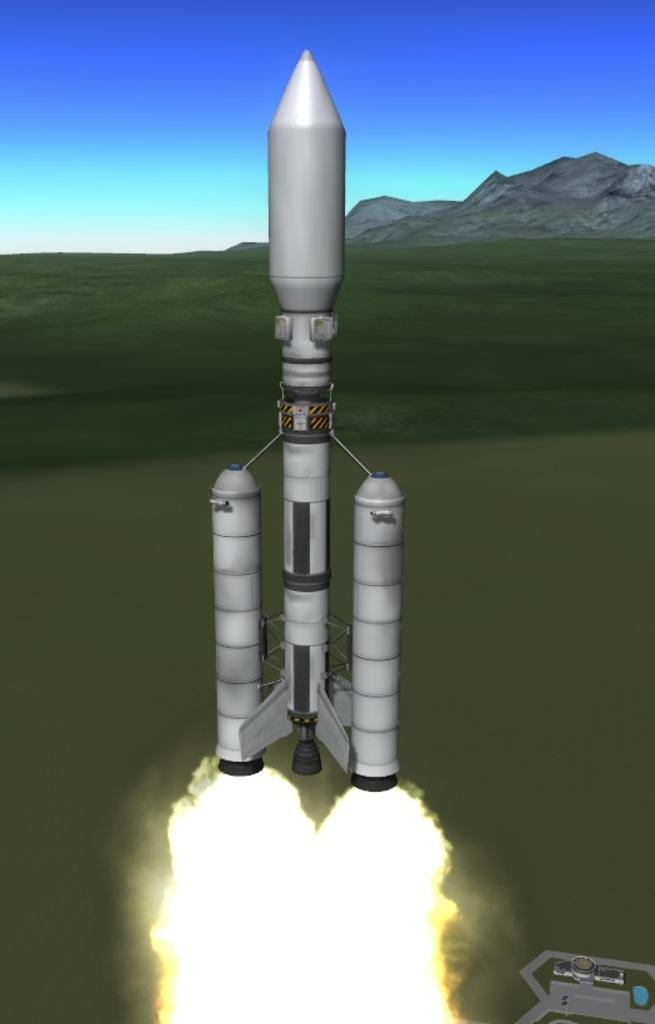What type of image is being described? The image is animated. What is the main subject in the front of the image? There is a rocket in the front of the image. What type of vegetation can be seen in the background of the image? There is grass in the background of the image. What type of geographical feature is visible in the background of the image? There are mountains in the background of the image. How many times has the rocket been copied in the image? The image does not show the rocket being copied, so it is not possible to determine how many times it has been copied. 